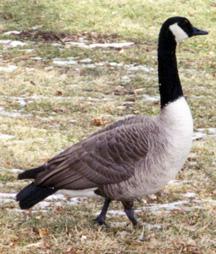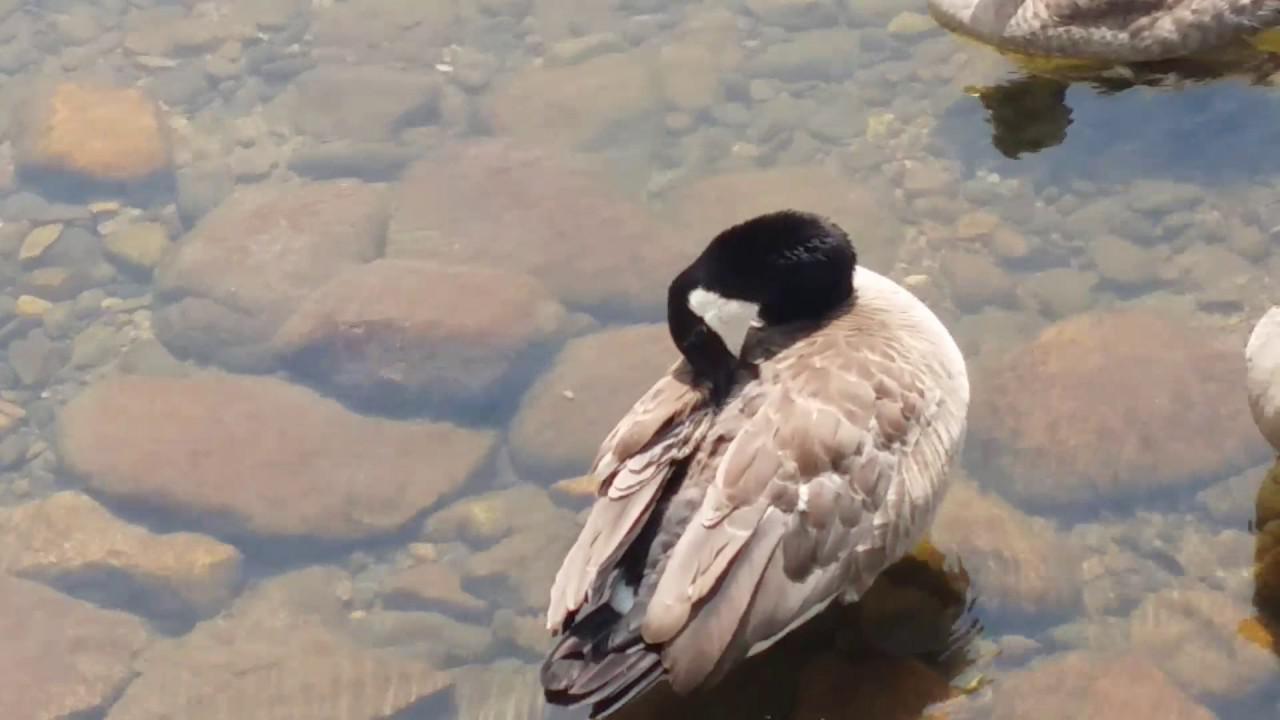The first image is the image on the left, the second image is the image on the right. For the images shown, is this caption "At least one of the birds is in a watery area." true? Answer yes or no. Yes. The first image is the image on the left, the second image is the image on the right. Examine the images to the left and right. Is the description "There are two adult black and brown geese visible" accurate? Answer yes or no. Yes. 